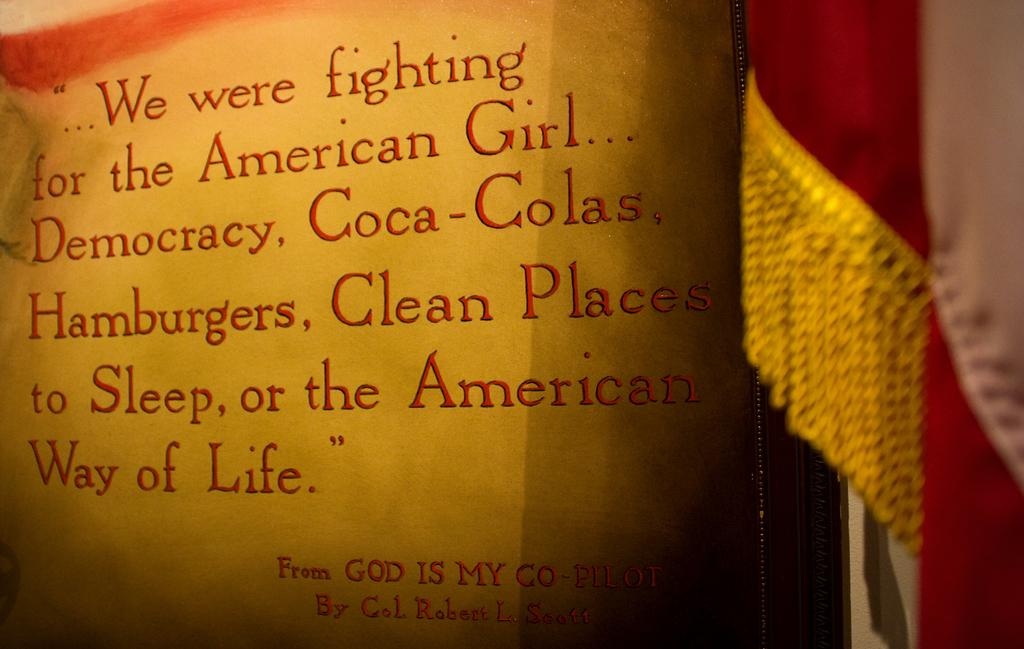What is the main feature of the red and yellow cloth in the image? There is writing on the red and yellow cloth in the image. Are there any other cloths visible in the image? Yes, there is another cloth visible in the image. How would you describe the background of the image? The background of the image is blurred. What type of hat is being used to cut the cloth in the image? There is no hat or cutting activity present in the image. 